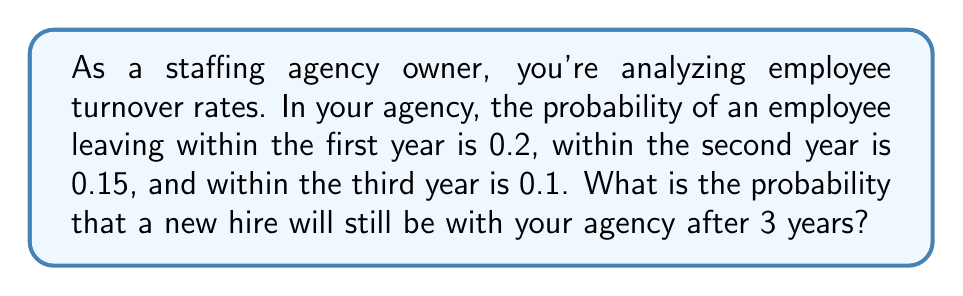Give your solution to this math problem. Let's approach this step-by-step:

1) First, we need to understand what the question is asking. We're looking for the probability of an employee staying with the agency for more than 3 years.

2) We're given the probabilities of an employee leaving in each of the first three years:
   - Year 1: $P(\text{leave in year 1}) = 0.2$
   - Year 2: $P(\text{leave in year 2}) = 0.15$
   - Year 3: $P(\text{leave in year 3}) = 0.1$

3) To find the probability of staying more than 3 years, we need to find the probability of not leaving in any of these years.

4) The probability of staying is the complement of the probability of leaving. So, for each year:
   - $P(\text{stay in year 1}) = 1 - 0.2 = 0.8$
   - $P(\text{stay in year 2}) = 1 - 0.15 = 0.85$
   - $P(\text{stay in year 3}) = 1 - 0.1 = 0.9$

5) For an employee to stay more than 3 years, they must stay in year 1 AND year 2 AND year 3. This is a case of independent events, so we multiply these probabilities:

   $P(\text{stay more than 3 years}) = 0.8 \times 0.85 \times 0.9$

6) Calculating this:
   $P(\text{stay more than 3 years}) = 0.8 \times 0.85 \times 0.9 = 0.612$

Therefore, the probability that a new hire will still be with your agency after 3 years is 0.612 or 61.2%.
Answer: 0.612 